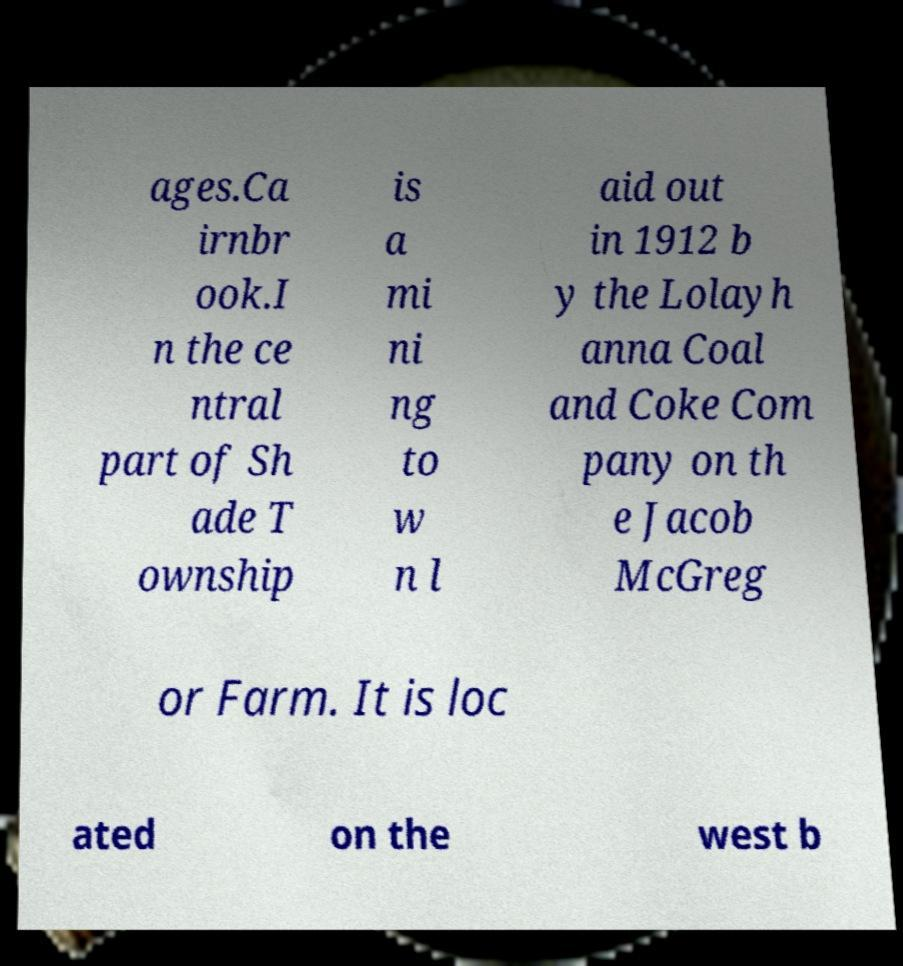What messages or text are displayed in this image? I need them in a readable, typed format. ages.Ca irnbr ook.I n the ce ntral part of Sh ade T ownship is a mi ni ng to w n l aid out in 1912 b y the Lolayh anna Coal and Coke Com pany on th e Jacob McGreg or Farm. It is loc ated on the west b 